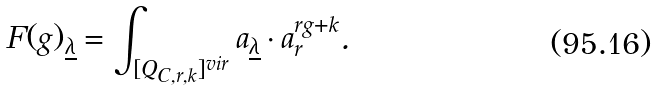<formula> <loc_0><loc_0><loc_500><loc_500>F ( g ) _ { \underline { \lambda } } = \int _ { [ Q _ { C , r , k } ] ^ { v i r } } a _ { \underline { \lambda } } \cdot a _ { r } ^ { r g + k } .</formula> 